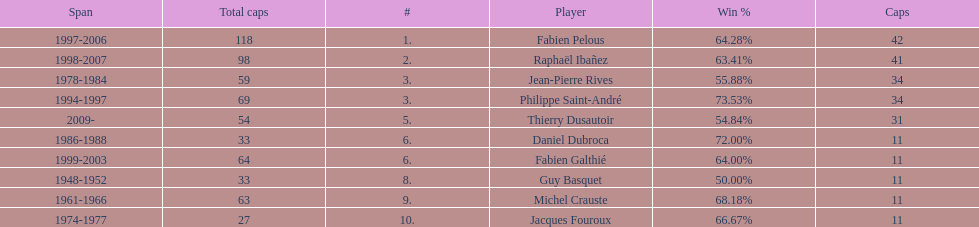How long did michel crauste serve as captain? 1961-1966. 